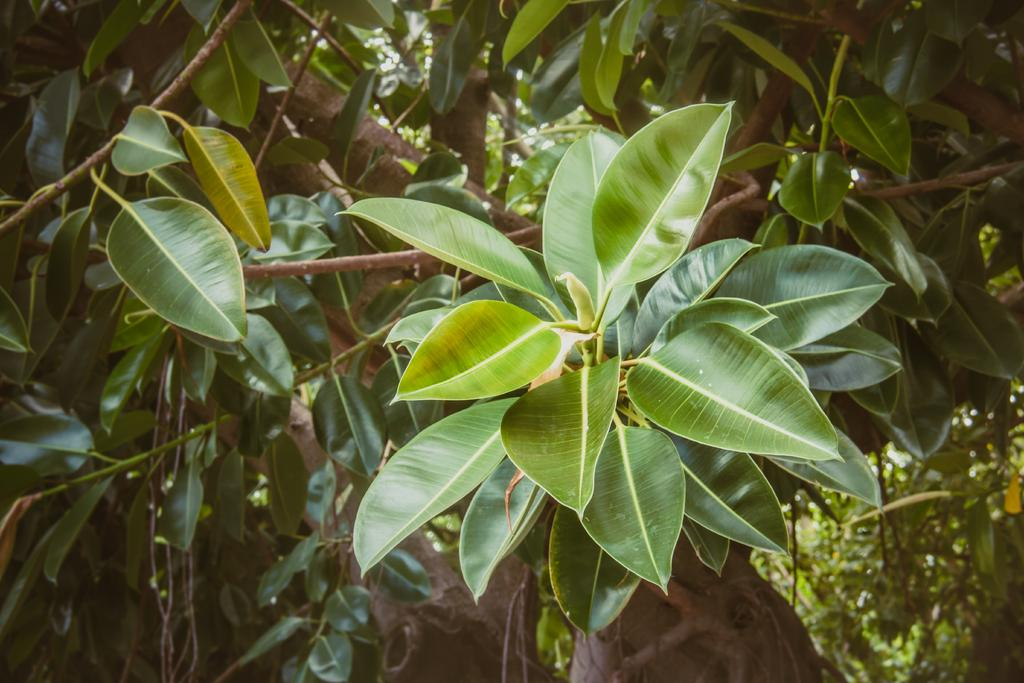What is present in the image? There is a tree in the image. What can be observed about the tree? The tree has leaves. What is the color of the leaves? The leaves are green in color. How many eyes can be seen on the tree in the image? There are no eyes present on the tree in the image, as trees do not have eyes. 